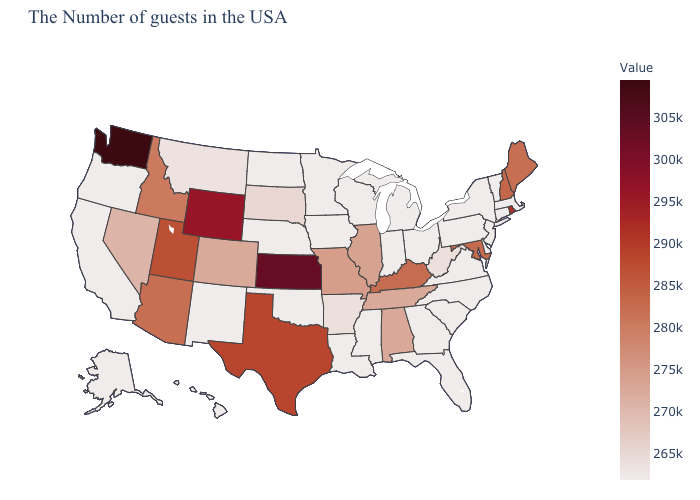Does Kentucky have a lower value than New Jersey?
Be succinct. No. Which states hav the highest value in the MidWest?
Concise answer only. Kansas. Which states have the lowest value in the USA?
Give a very brief answer. Massachusetts, Vermont, Connecticut, New York, New Jersey, Delaware, Pennsylvania, Virginia, North Carolina, South Carolina, Ohio, Florida, Georgia, Michigan, Indiana, Wisconsin, Mississippi, Louisiana, Minnesota, Iowa, Nebraska, Oklahoma, North Dakota, New Mexico, California, Oregon, Alaska, Hawaii. Among the states that border Nevada , which have the lowest value?
Be succinct. California, Oregon. 